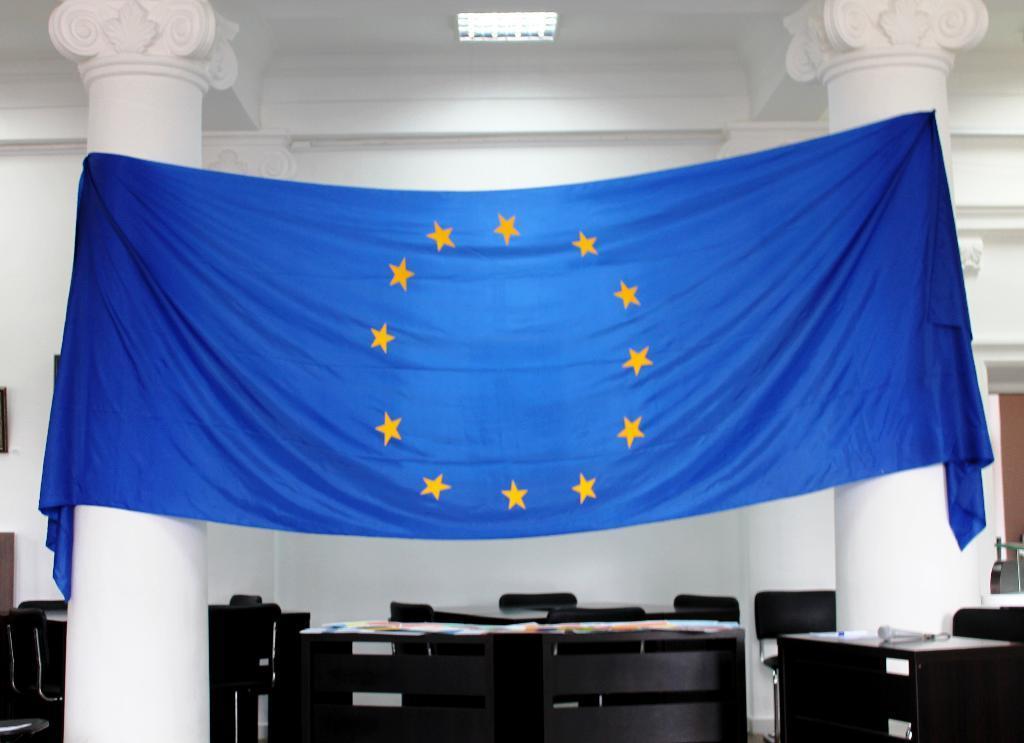Describe this image in one or two sentences. In this picture we can see a cloth which is in blue color. These are the pillars. There are chairs and this is table. On the background there is a wall. And this is light. 